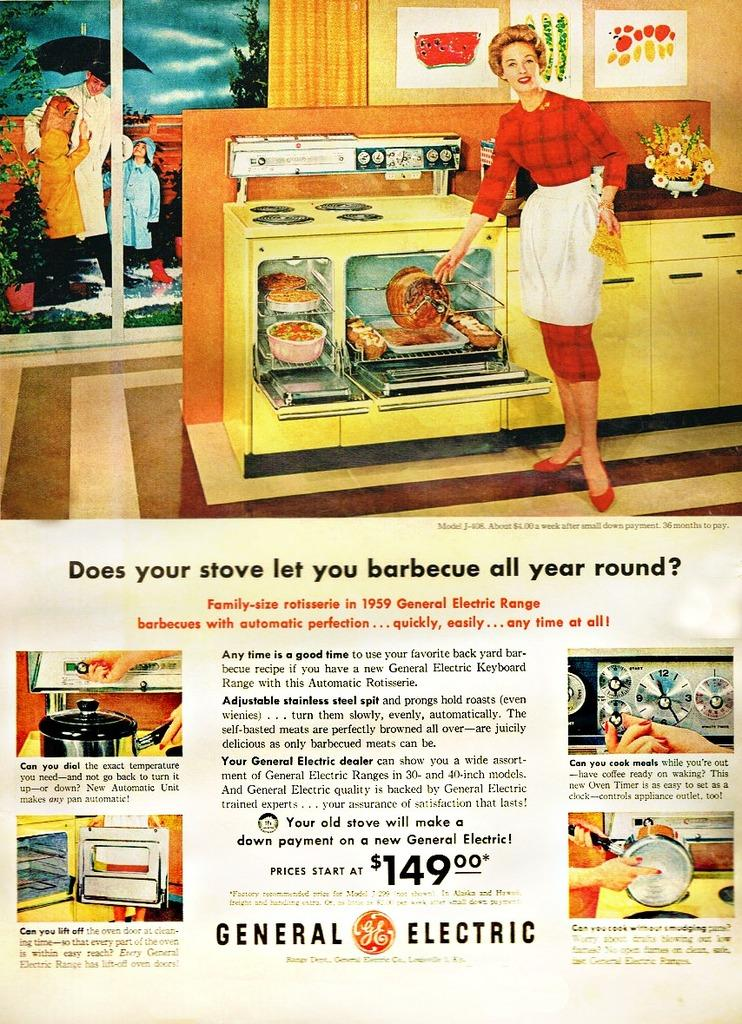<image>
Offer a succinct explanation of the picture presented. A General Electric advertisement about a stove priced at $149.00.. 